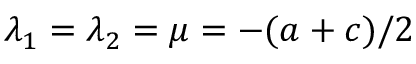<formula> <loc_0><loc_0><loc_500><loc_500>\lambda _ { 1 } = \lambda _ { 2 } = \mu = - ( a + c ) / 2</formula> 